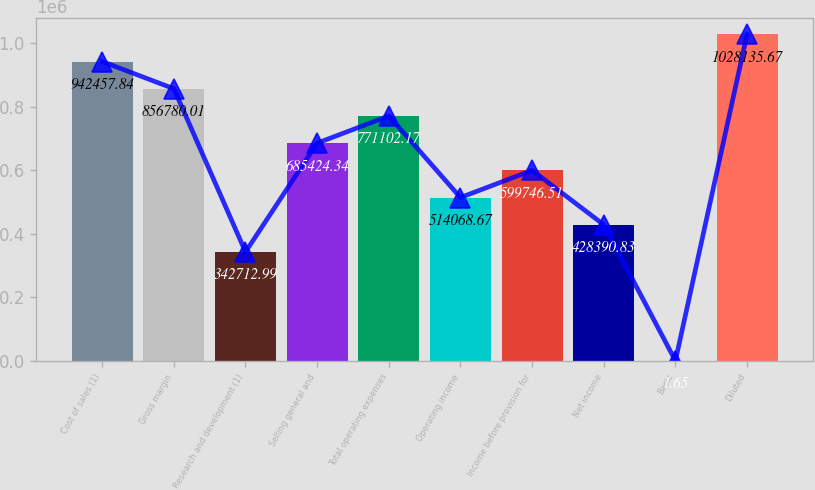<chart> <loc_0><loc_0><loc_500><loc_500><bar_chart><fcel>Cost of sales (1)<fcel>Gross margin<fcel>Research and development (1)<fcel>Selling general and<fcel>Total operating expenses<fcel>Operating income<fcel>Income before provision for<fcel>Net income<fcel>Basic<fcel>Diluted<nl><fcel>942458<fcel>856780<fcel>342713<fcel>685424<fcel>771102<fcel>514069<fcel>599747<fcel>428391<fcel>1.65<fcel>1.02814e+06<nl></chart> 